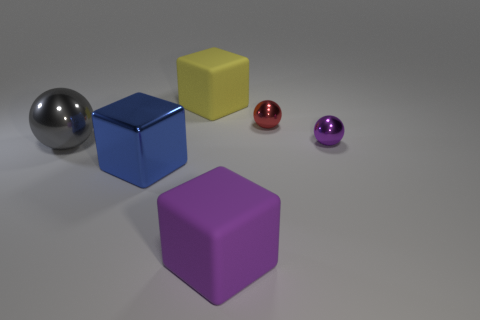Add 2 big yellow matte spheres. How many objects exist? 8 Subtract 1 blue cubes. How many objects are left? 5 Subtract all purple blocks. Subtract all small things. How many objects are left? 3 Add 5 big metal objects. How many big metal objects are left? 7 Add 5 blue things. How many blue things exist? 6 